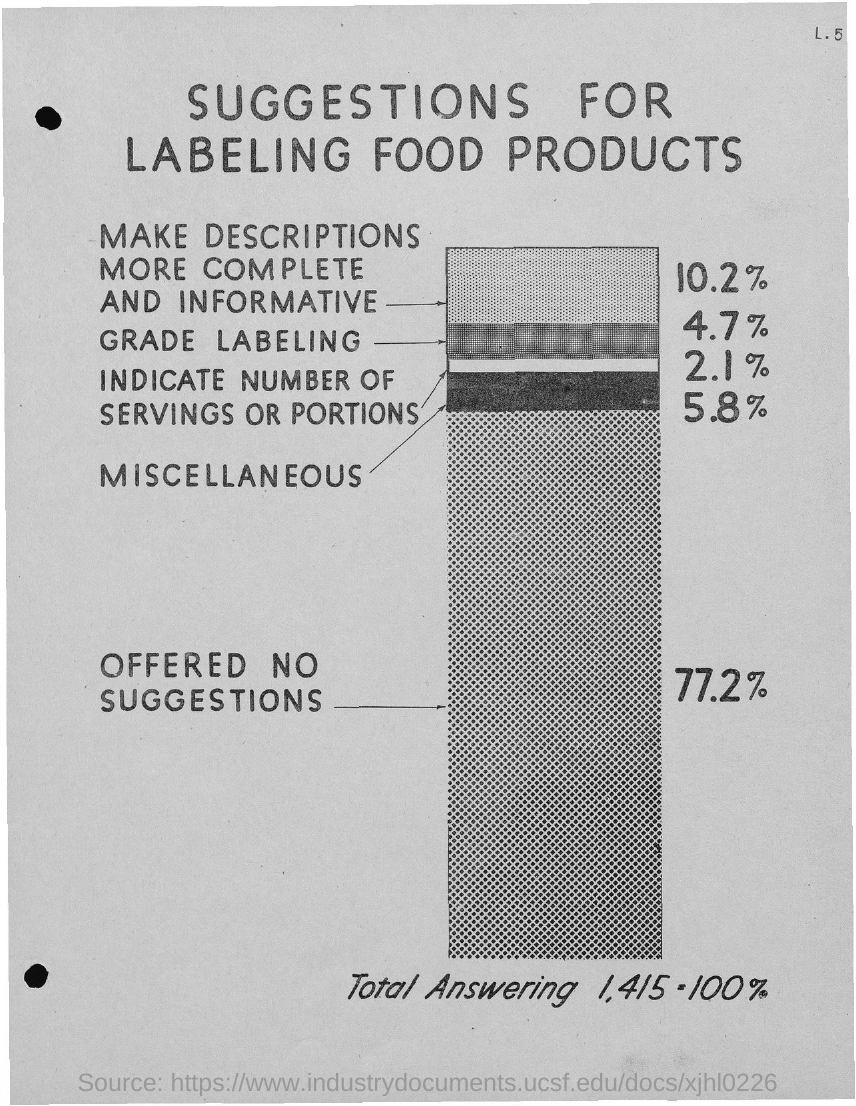What is the title of the document?
Your answer should be compact. SUGGESTIONS FOR LABELING FOOD PRODUCTS. 